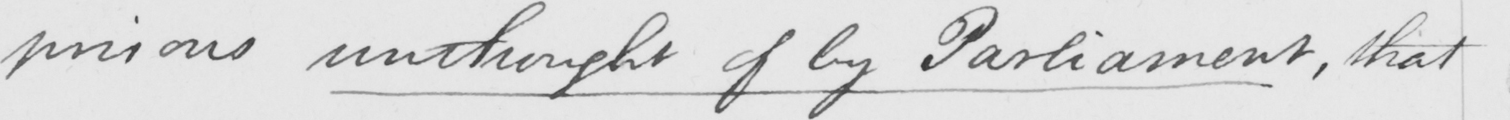What is written in this line of handwriting? prisons unthought of by Parliament , that 